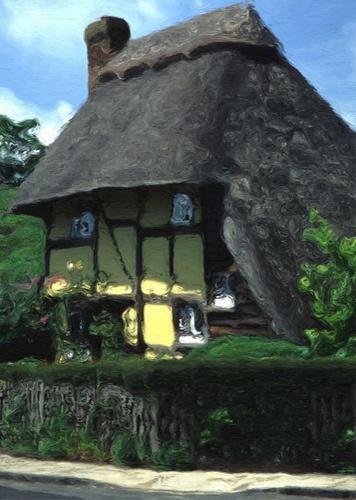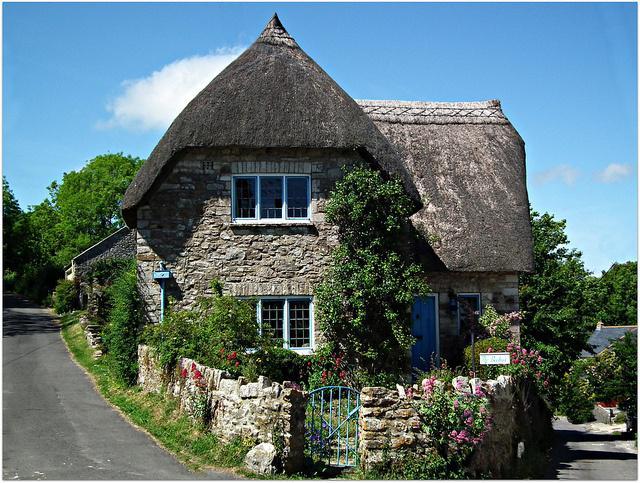The first image is the image on the left, the second image is the image on the right. Considering the images on both sides, is "In at least one image there is a white house with black stripes of wood that create a box look." valid? Answer yes or no. No. The first image is the image on the left, the second image is the image on the right. Analyze the images presented: Is the assertion "The left image shows the front of a white house with bold dark lines on it forming geometric patterns, a chimney on at least one end, and a thick grayish peaked roof with a sculptural border along the top edge." valid? Answer yes or no. No. 